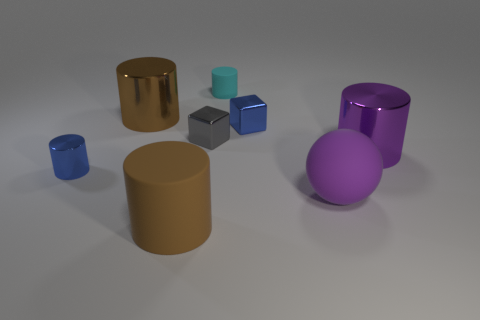The small thing that is the same color as the small shiny cylinder is what shape?
Offer a very short reply. Cube. What color is the metallic cylinder that is behind the big cylinder on the right side of the big purple rubber thing?
Your response must be concise. Brown. There is a small rubber thing that is the same shape as the large brown matte object; what is its color?
Give a very brief answer. Cyan. Are there any other things that have the same material as the large purple ball?
Make the answer very short. Yes. There is a blue metal object that is the same shape as the big brown metallic thing; what is its size?
Your answer should be compact. Small. There is a brown cylinder that is to the left of the brown rubber cylinder; what is it made of?
Offer a very short reply. Metal. Are there fewer purple metal cylinders behind the cyan matte cylinder than yellow cubes?
Give a very brief answer. No. The large rubber object that is on the right side of the blue shiny object behind the gray cube is what shape?
Your answer should be very brief. Sphere. The tiny matte object is what color?
Your answer should be compact. Cyan. What number of other objects are there of the same size as the blue block?
Ensure brevity in your answer.  3. 